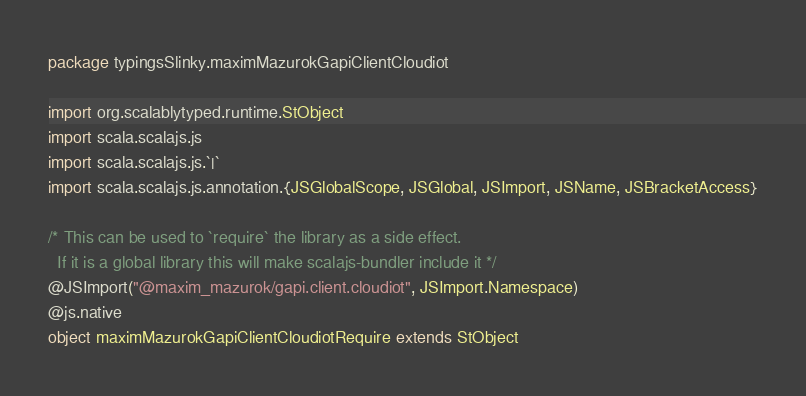<code> <loc_0><loc_0><loc_500><loc_500><_Scala_>package typingsSlinky.maximMazurokGapiClientCloudiot

import org.scalablytyped.runtime.StObject
import scala.scalajs.js
import scala.scalajs.js.`|`
import scala.scalajs.js.annotation.{JSGlobalScope, JSGlobal, JSImport, JSName, JSBracketAccess}

/* This can be used to `require` the library as a side effect.
  If it is a global library this will make scalajs-bundler include it */
@JSImport("@maxim_mazurok/gapi.client.cloudiot", JSImport.Namespace)
@js.native
object maximMazurokGapiClientCloudiotRequire extends StObject
</code> 